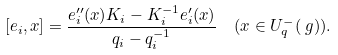Convert formula to latex. <formula><loc_0><loc_0><loc_500><loc_500>[ e _ { i } , x ] = \frac { e _ { i } ^ { \prime \prime } ( x ) K _ { i } - K _ { i } ^ { - 1 } e _ { i } ^ { \prime } ( x ) } { q _ { i } - q _ { i } ^ { - 1 } } & \quad ( x \in U _ { q } ^ { - } ( \ g ) ) .</formula> 